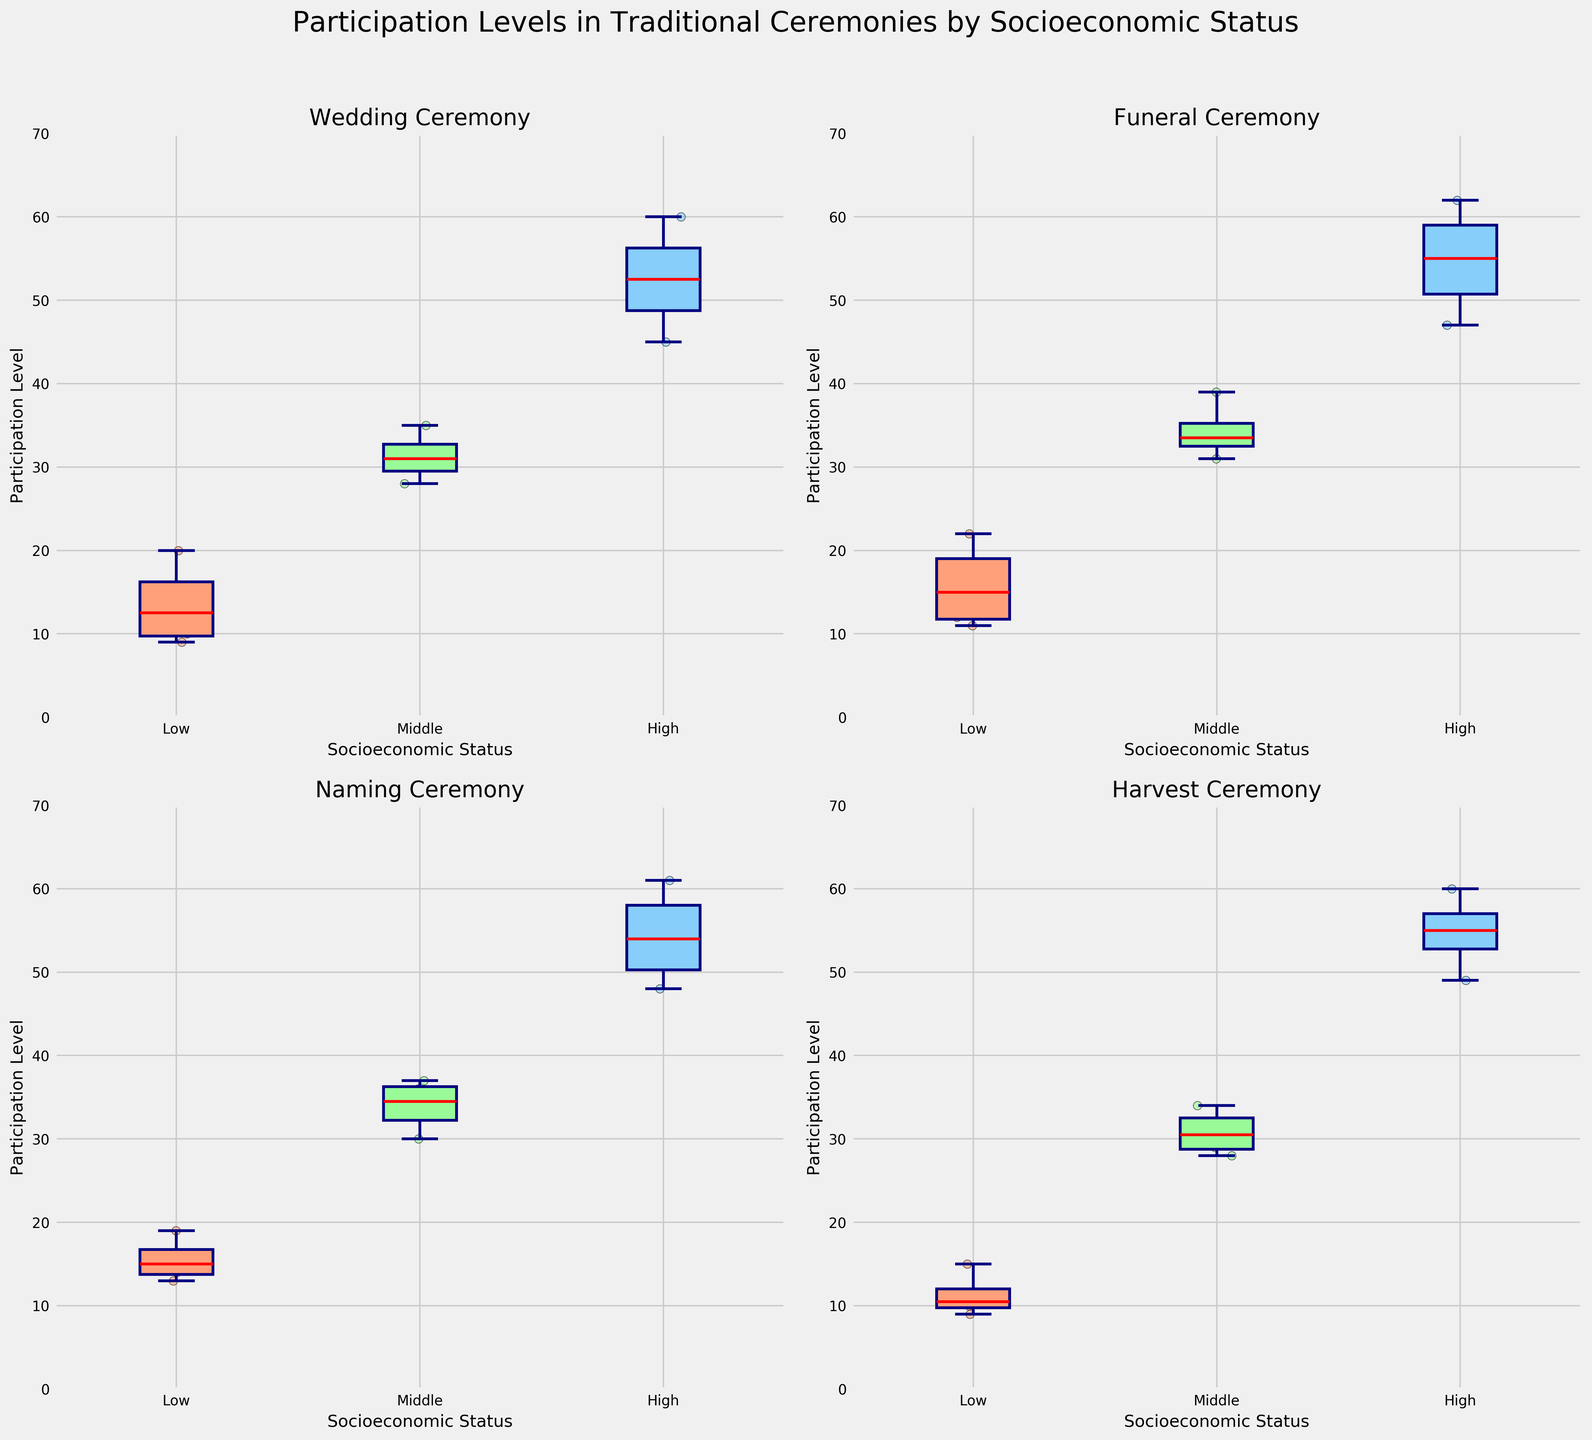What is the title of the figure? The title is located at the top of the figure. It reads "Participation Levels in Traditional Ceremonies by Socioeconomic Status".
Answer: Participation Levels in Traditional Ceremonies by Socioeconomic Status Which socioeconomic group has the highest participation level in the Wedding ceremony? The highest boxes and whiskers for the Wedding ceremony are found in the "High" socioeconomic group on the Wedding subplot at the top left.
Answer: High How do the participation levels of the Low socioeconomic group vary across different ceremonies? For the Low socioeconomic group, observe the box plots in each subplot: Wedding, Funeral, Naming, and Harvest. Look at the range of the boxes and the position of the whiskers.
Answer: They range from around 9 to 22 What is the median participation level for the Middle socioeconomic group in the Naming ceremony? The median is represented by the red line within the box plot. Locate the middle red line in the Middle box of the Naming subplot at the bottom left.
Answer: Approximately 34 Which ceremony has the widest range of participation levels for the High socioeconomic group? The range is the difference between the highest and lowest points of the whiskers. Compare the High socioeconomic group's whisker length in each subplot.
Answer: Funeral Is there a significant difference in the median participation levels between the Low and High socioeconomic groups in the Harvest ceremony? The red lines in the boxplots represent the medians. Compare the medians for the Low and High groups in the Harvest subplot at the bottom right.
Answer: Yes, the High group has a much higher median What is the general trend in participation levels across socioeconomic statuses for the Funeral ceremony? Examine the direction of the boxes and whiskers from Low to High socioeconomic groups in the Funeral subplot at the top right.
Answer: Increasing trend Which socioeconomic status group shows the most consistent participation levels across all ceremonies? Consistency can be assessed by looking at the spread of the boxes and whiskers across all four subplots. The narrower the boxes and whiskers, the more consistent the data.
Answer: High In which ceremony does the Low socioeconomic group show the smallest variation in participation levels? The smallest variation in the Low socioeconomic group's participation levels can be seen by finding the smallest range of the whiskers in the Low group across all ceremonies.
Answer: Naming How do participation levels compare between the Middle socioeconomic group for the Naming and Harvest ceremonies? Compare the boxes and median lines of the Middle group in the Naming subplot (bottom left) and Harvest subplot (bottom right).
Answer: The Naming levels are slightly higher and more consistent 